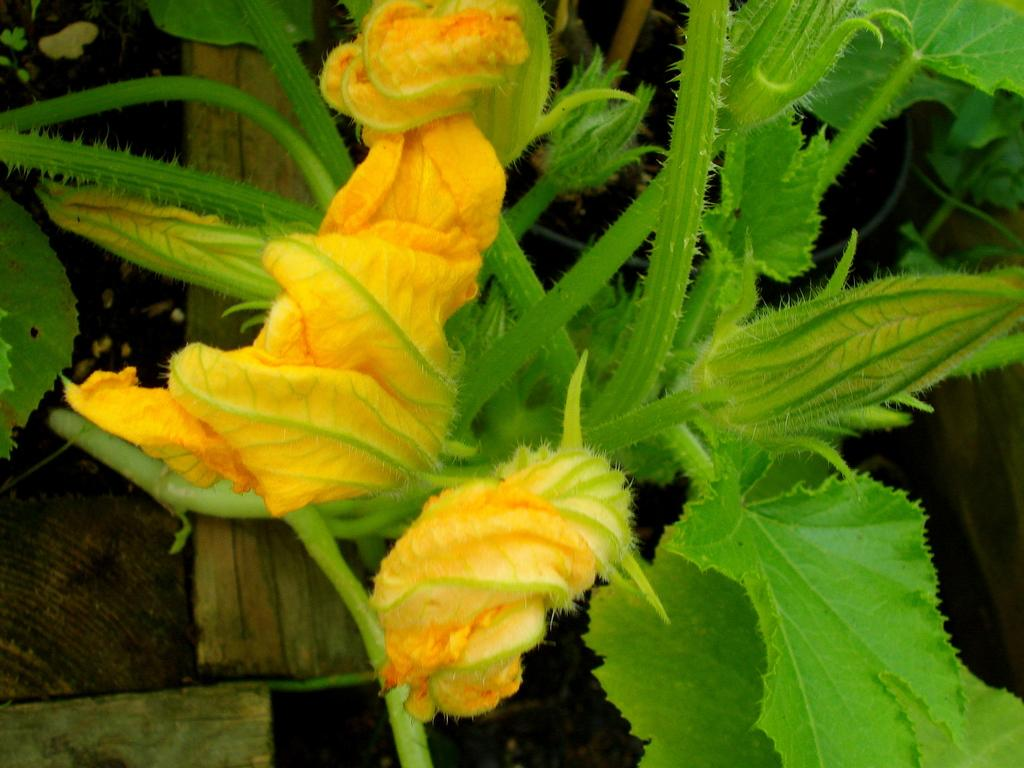What type of plant is visible in the image? There is a plant with flowers in the image. Can you describe any other objects or features in the image? There is a wooden object in the background of the image. What type of card is being used to give the plant a haircut in the image? There is no card or haircut present in the image; it features a plant with flowers and a wooden object in the background. 